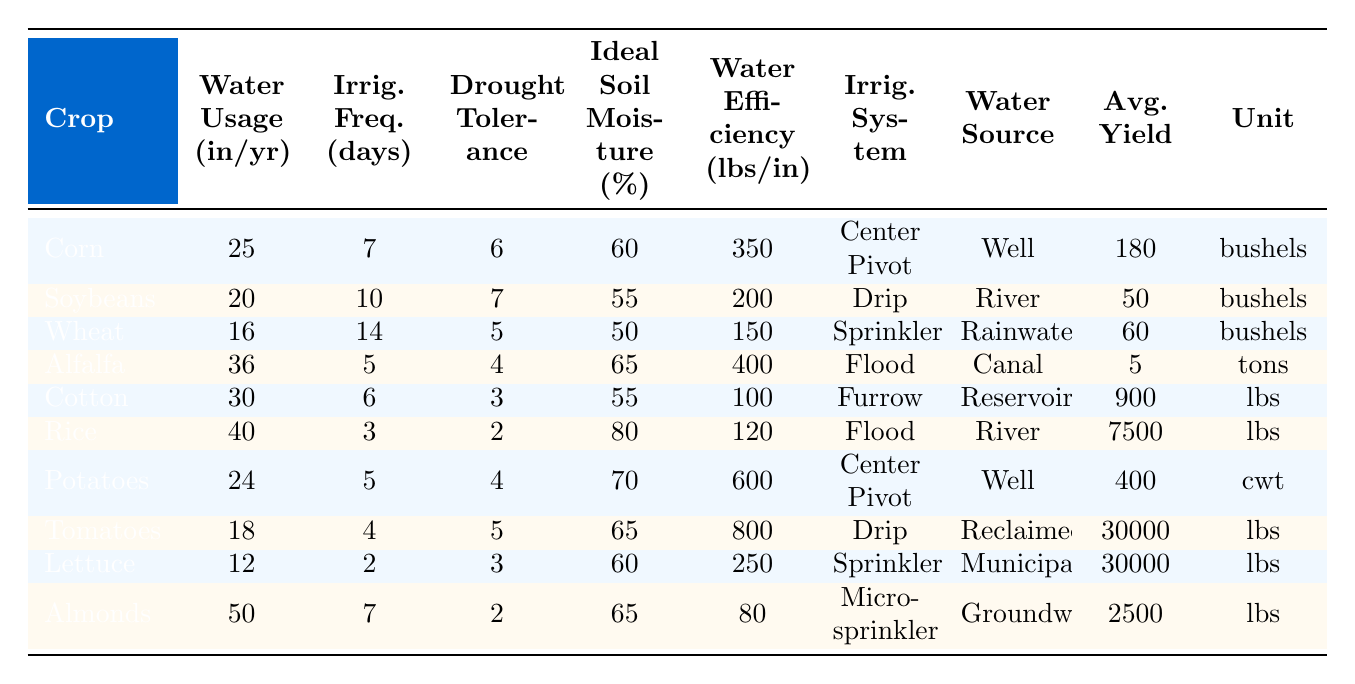What is the water usage for Rice? The water usage for Rice can be found in the "Water Usage (in/yr)" column, where Rice has an annual water usage of 40 inches.
Answer: 40 inches Which crop has the highest average yield per acre? To find the crop with the highest yield, we look at the "Avg. Yield" column. Tomatoes have the highest yield at 30,000 lbs.
Answer: Tomatoes What is the irrigation frequency for Corn? From the "Irrig. Freq. (days)" column, Corn has an irrigation frequency of 7 days.
Answer: 7 days Is Alfalfa more drought-tolerant than Cotton? By comparing the "Drought Tolerance" values, Alfalfa has a rating of 4, while Cotton has a rating of 3, which means Alfalfa is more drought-tolerant.
Answer: Yes What is the difference in water usage between Lettuce and Wheat? The water usage for Lettuce is 12 inches and for Wheat is 16 inches. The difference is 16 - 12 = 4 inches.
Answer: 4 inches How many crops have an irrigation frequency of 6 days? By analyzing the "Irrig. Freq. (days)" column, Cotton and Alfalfa both have an irrigation frequency of 6 days, resulting in a total of 2 crops.
Answer: 2 crops Which crop uses the least water and what is that amount? In the "Water Usage (in/yr)" column, Wheat has the least water usage at 16 inches per year.
Answer: 16 inches What is the average water usage for all crops? The water usage values are added together: (25 + 20 + 16 + 36 + 30 + 40 + 24 + 18 + 12 + 50) =  291 inches. There are 10 crops, so average = 291 / 10 = 29.1 inches.
Answer: 29.1 inches Which irrigation system is used for the most water-efficient crop? The most water-efficient crop is Potatoes, with a water use efficiency of 600 lbs/in. The irrigation system for Potatoes is Center Pivot.
Answer: Center Pivot Which crop requires the most frequent irrigation? The irrigation frequency of the crops shows that Rice, with a frequency of 3 days, requires the most frequent irrigation.
Answer: Rice 